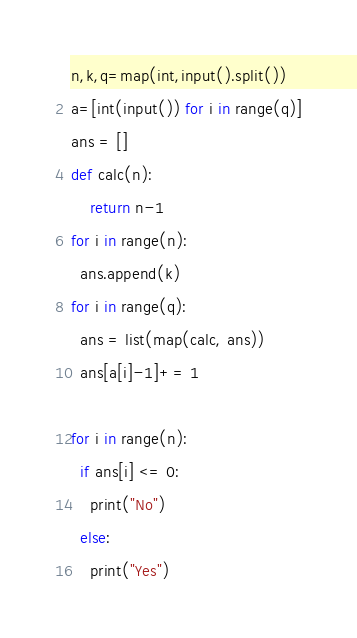Convert code to text. <code><loc_0><loc_0><loc_500><loc_500><_Python_>n,k,q=map(int,input().split())
a=[int(input()) for i in range(q)]
ans = []
def calc(n):
    return n-1
for i in range(n):
  ans.append(k)
for i in range(q):
  ans = list(map(calc, ans))
  ans[a[i]-1]+= 1

for i in range(n):
  if ans[i] <= 0:
    print("No")
  else:
    print("Yes")</code> 